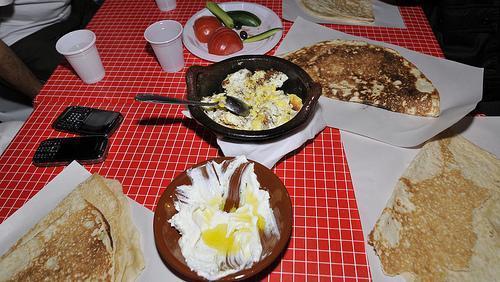How many phones on table?
Give a very brief answer. 2. How many cups are there?
Give a very brief answer. 3. 